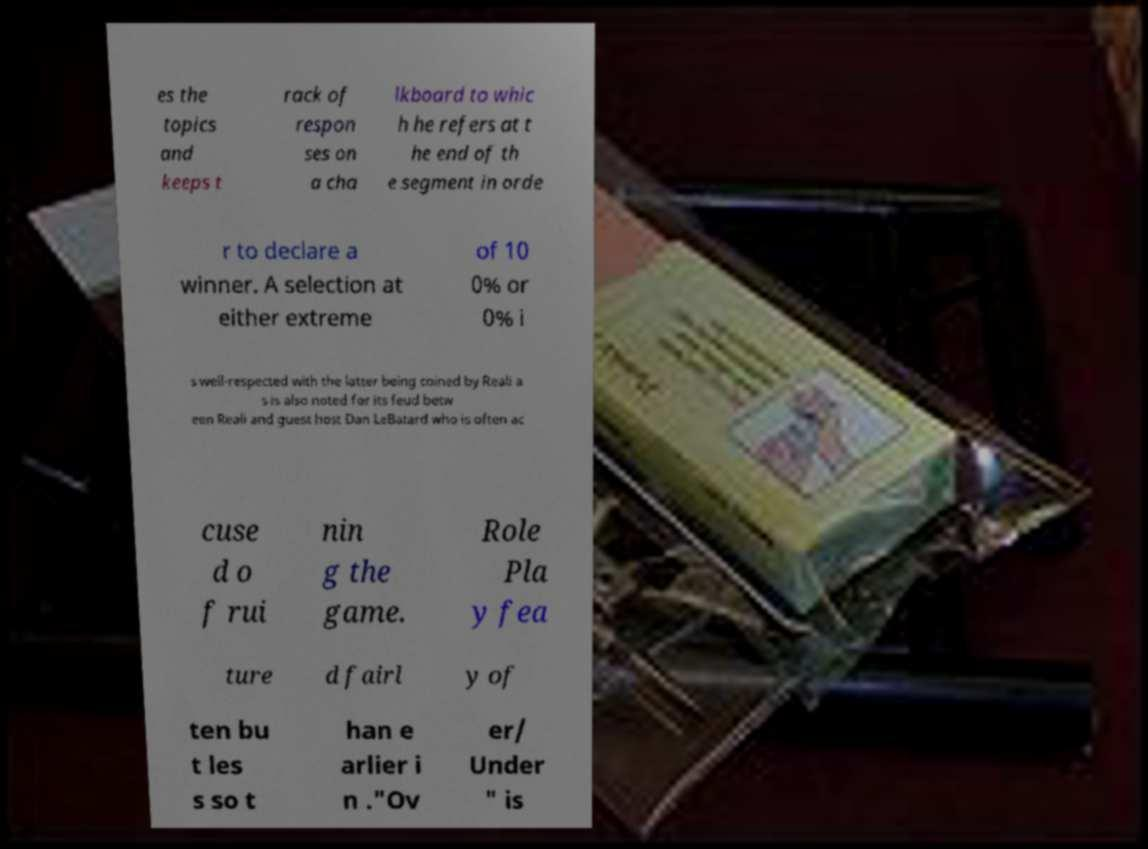There's text embedded in this image that I need extracted. Can you transcribe it verbatim? es the topics and keeps t rack of respon ses on a cha lkboard to whic h he refers at t he end of th e segment in orde r to declare a winner. A selection at either extreme of 10 0% or 0% i s well-respected with the latter being coined by Reali a s is also noted for its feud betw een Reali and guest host Dan LeBatard who is often ac cuse d o f rui nin g the game. Role Pla y fea ture d fairl y of ten bu t les s so t han e arlier i n ."Ov er/ Under " is 